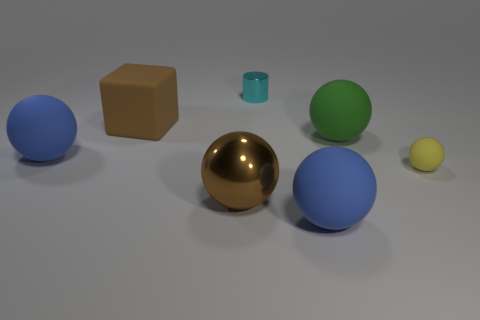Subtract all green spheres. How many spheres are left? 4 Add 2 gray metal balls. How many objects exist? 9 Subtract all green spheres. How many spheres are left? 4 Subtract 1 spheres. How many spheres are left? 4 Subtract all yellow spheres. Subtract all cyan cylinders. How many spheres are left? 4 Subtract all balls. How many objects are left? 2 Subtract all gray spheres. Subtract all big brown metallic things. How many objects are left? 6 Add 6 big shiny objects. How many big shiny objects are left? 7 Add 6 yellow rubber balls. How many yellow rubber balls exist? 7 Subtract 0 cyan cubes. How many objects are left? 7 